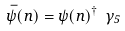Convert formula to latex. <formula><loc_0><loc_0><loc_500><loc_500>\bar { \psi } ( n ) = \psi ( n ) ^ { \dagger } \ \gamma _ { 5 }</formula> 